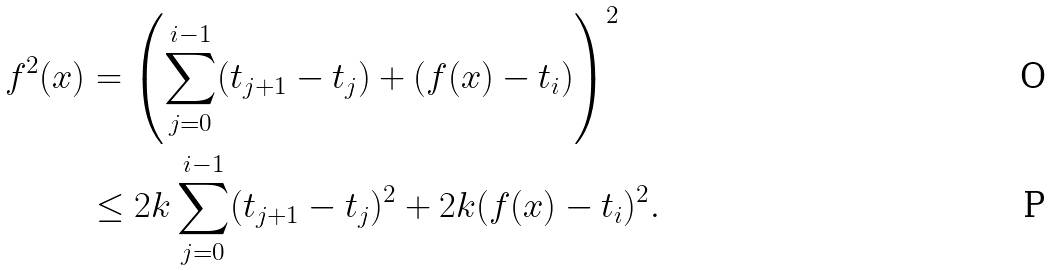<formula> <loc_0><loc_0><loc_500><loc_500>f ^ { 2 } ( x ) & = \left ( \sum _ { j = 0 } ^ { i - 1 } ( t _ { j + 1 } - t _ { j } ) + ( f ( x ) - t _ { i } ) \right ) ^ { 2 } \\ & \leq 2 k \sum _ { j = 0 } ^ { i - 1 } ( t _ { j + 1 } - t _ { j } ) ^ { 2 } + 2 k ( f ( x ) - t _ { i } ) ^ { 2 } .</formula> 